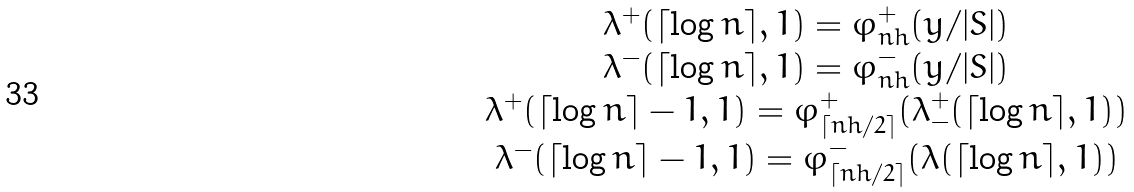Convert formula to latex. <formula><loc_0><loc_0><loc_500><loc_500>\begin{array} { c c } \lambda ^ { + } ( \lceil \log n \rceil , 1 ) = \varphi _ { n h } ^ { + } ( y / | S | ) \\ \lambda ^ { - } ( \lceil \log n \rceil , 1 ) = \varphi _ { n h } ^ { - } ( y / | S | ) \\ \lambda ^ { + } ( \lceil \log n \rceil - 1 , 1 ) = \varphi _ { \lceil n h / 2 \rceil } ^ { + } ( \lambda _ { - } ^ { + } ( \lceil \log n \rceil , 1 ) ) \\ \lambda ^ { - } ( \lceil \log n \rceil - 1 , 1 ) = \varphi _ { \lceil n h / 2 \rceil } ^ { - } ( \lambda ( \lceil \log n \rceil , 1 ) ) \end{array}</formula> 